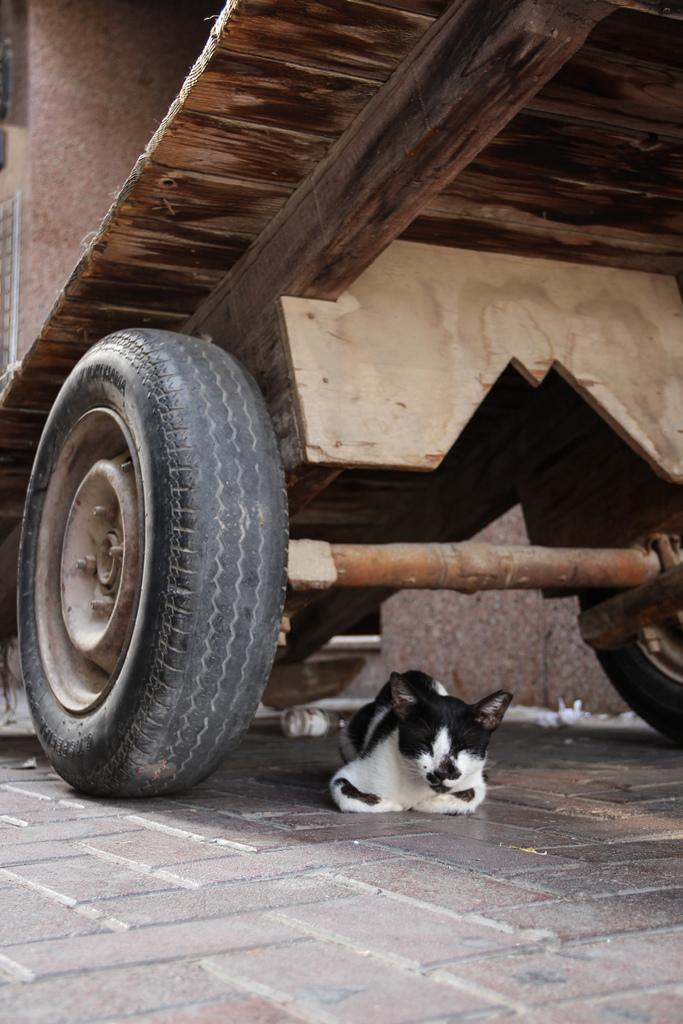What animal is on the floor in the image? There is a cat on the floor in the image. What type of object is visible in the image? There is a vehicle in the image. What can be seen in the background of the image? There is a wall in the background of the image. What type of poison is the cat using to control the vehicle in the image? There is no poison or control of a vehicle by the cat in the image; the cat is simply on the floor, and the vehicle is a separate object. 